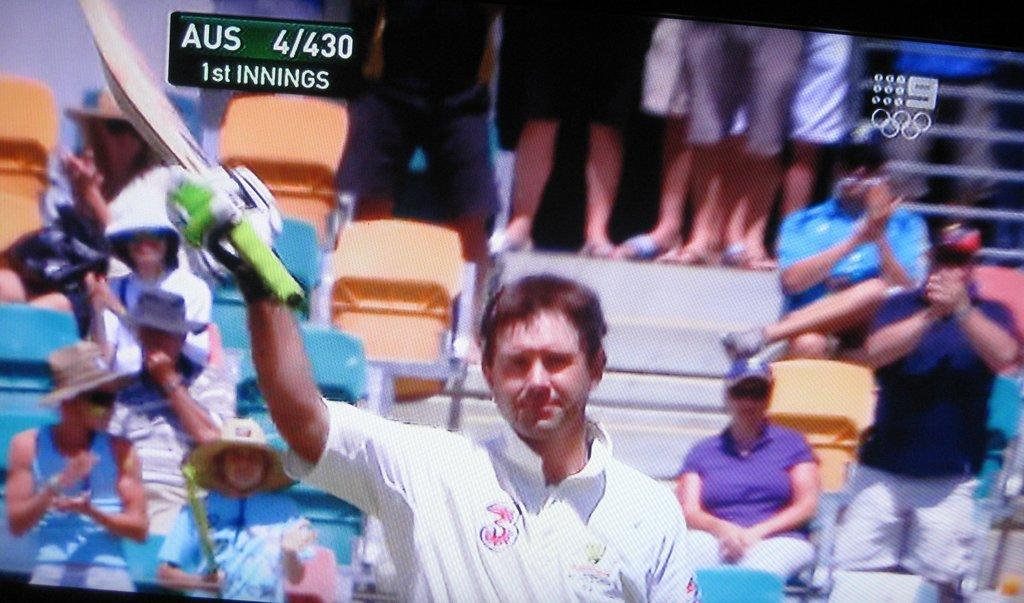Who is present in the image? There is a person in the image. What is the person wearing? The person is wearing a white t-shirt. What is the person holding in the image? The person is holding a bat. Are there any other people in the image? Yes, there are other people present in the image. What type of hammer is the person using to hit the bears in the image? There is no hammer or bears present in the image. The person is holding a bat, not a hammer, and there is no mention of bears in the provided facts. 